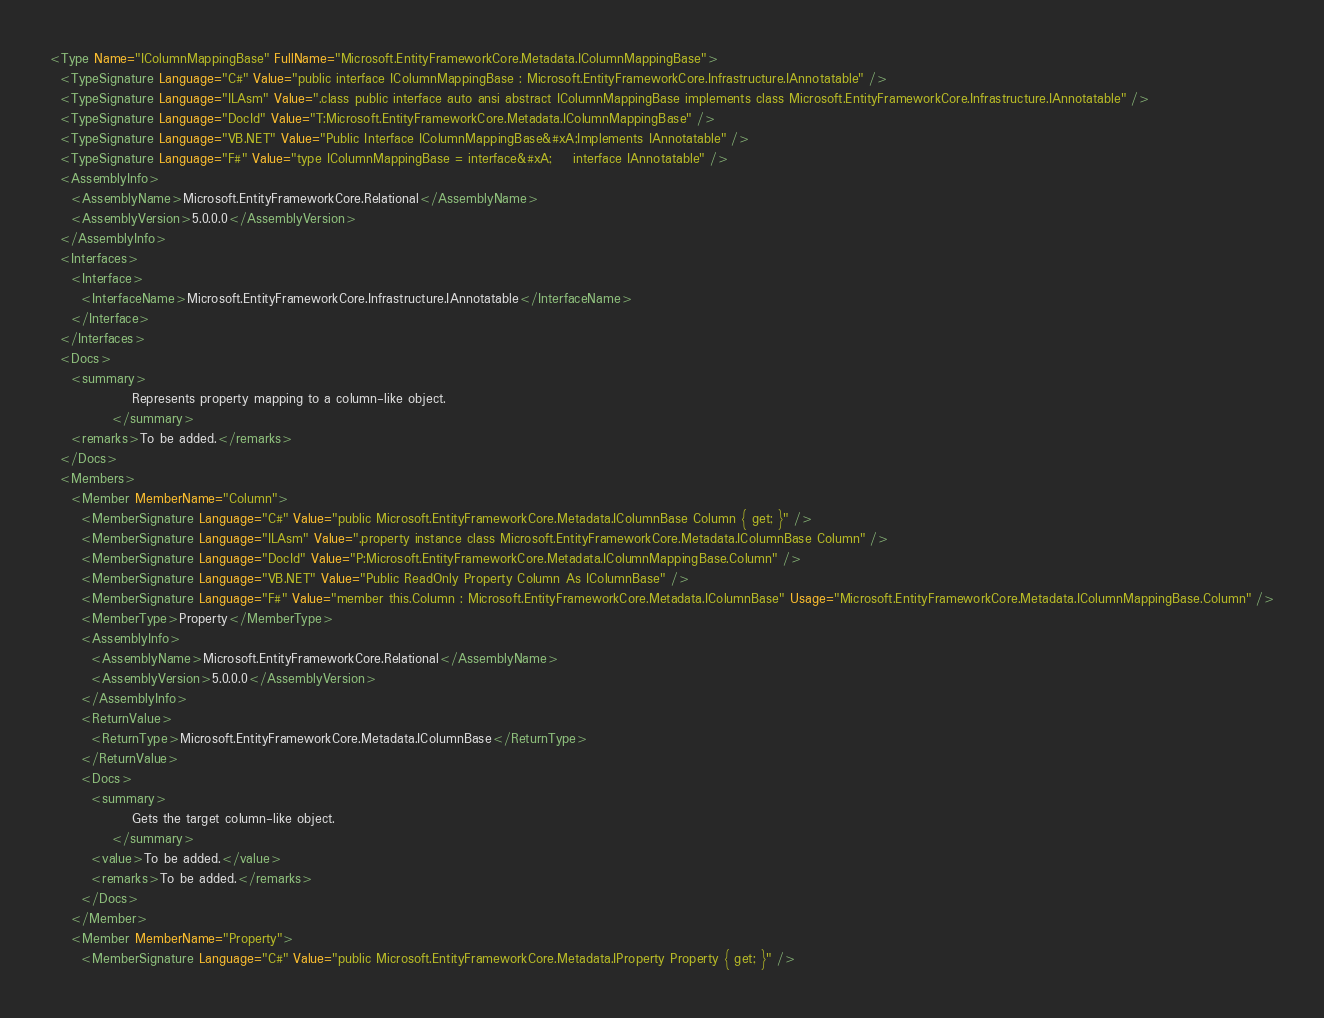<code> <loc_0><loc_0><loc_500><loc_500><_XML_><Type Name="IColumnMappingBase" FullName="Microsoft.EntityFrameworkCore.Metadata.IColumnMappingBase">
  <TypeSignature Language="C#" Value="public interface IColumnMappingBase : Microsoft.EntityFrameworkCore.Infrastructure.IAnnotatable" />
  <TypeSignature Language="ILAsm" Value=".class public interface auto ansi abstract IColumnMappingBase implements class Microsoft.EntityFrameworkCore.Infrastructure.IAnnotatable" />
  <TypeSignature Language="DocId" Value="T:Microsoft.EntityFrameworkCore.Metadata.IColumnMappingBase" />
  <TypeSignature Language="VB.NET" Value="Public Interface IColumnMappingBase&#xA;Implements IAnnotatable" />
  <TypeSignature Language="F#" Value="type IColumnMappingBase = interface&#xA;    interface IAnnotatable" />
  <AssemblyInfo>
    <AssemblyName>Microsoft.EntityFrameworkCore.Relational</AssemblyName>
    <AssemblyVersion>5.0.0.0</AssemblyVersion>
  </AssemblyInfo>
  <Interfaces>
    <Interface>
      <InterfaceName>Microsoft.EntityFrameworkCore.Infrastructure.IAnnotatable</InterfaceName>
    </Interface>
  </Interfaces>
  <Docs>
    <summary>
                Represents property mapping to a column-like object.
            </summary>
    <remarks>To be added.</remarks>
  </Docs>
  <Members>
    <Member MemberName="Column">
      <MemberSignature Language="C#" Value="public Microsoft.EntityFrameworkCore.Metadata.IColumnBase Column { get; }" />
      <MemberSignature Language="ILAsm" Value=".property instance class Microsoft.EntityFrameworkCore.Metadata.IColumnBase Column" />
      <MemberSignature Language="DocId" Value="P:Microsoft.EntityFrameworkCore.Metadata.IColumnMappingBase.Column" />
      <MemberSignature Language="VB.NET" Value="Public ReadOnly Property Column As IColumnBase" />
      <MemberSignature Language="F#" Value="member this.Column : Microsoft.EntityFrameworkCore.Metadata.IColumnBase" Usage="Microsoft.EntityFrameworkCore.Metadata.IColumnMappingBase.Column" />
      <MemberType>Property</MemberType>
      <AssemblyInfo>
        <AssemblyName>Microsoft.EntityFrameworkCore.Relational</AssemblyName>
        <AssemblyVersion>5.0.0.0</AssemblyVersion>
      </AssemblyInfo>
      <ReturnValue>
        <ReturnType>Microsoft.EntityFrameworkCore.Metadata.IColumnBase</ReturnType>
      </ReturnValue>
      <Docs>
        <summary>
                Gets the target column-like object.
            </summary>
        <value>To be added.</value>
        <remarks>To be added.</remarks>
      </Docs>
    </Member>
    <Member MemberName="Property">
      <MemberSignature Language="C#" Value="public Microsoft.EntityFrameworkCore.Metadata.IProperty Property { get; }" /></code> 